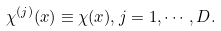<formula> <loc_0><loc_0><loc_500><loc_500>\chi ^ { ( j ) } ( x ) \equiv \chi ( x ) , j = 1 , \cdots , D .</formula> 